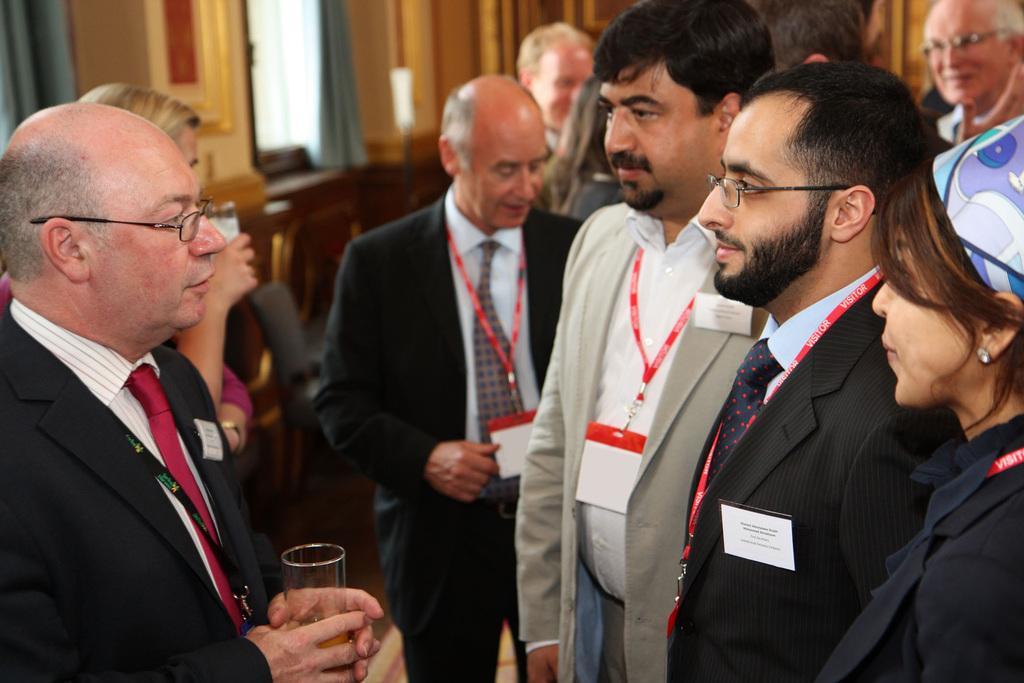Please provide a concise description of this image. In the picture I can see groups of people. On the right side of the image I can see one person standing and holding the glass. On the left side of the image I can see one object in one girls hair. 